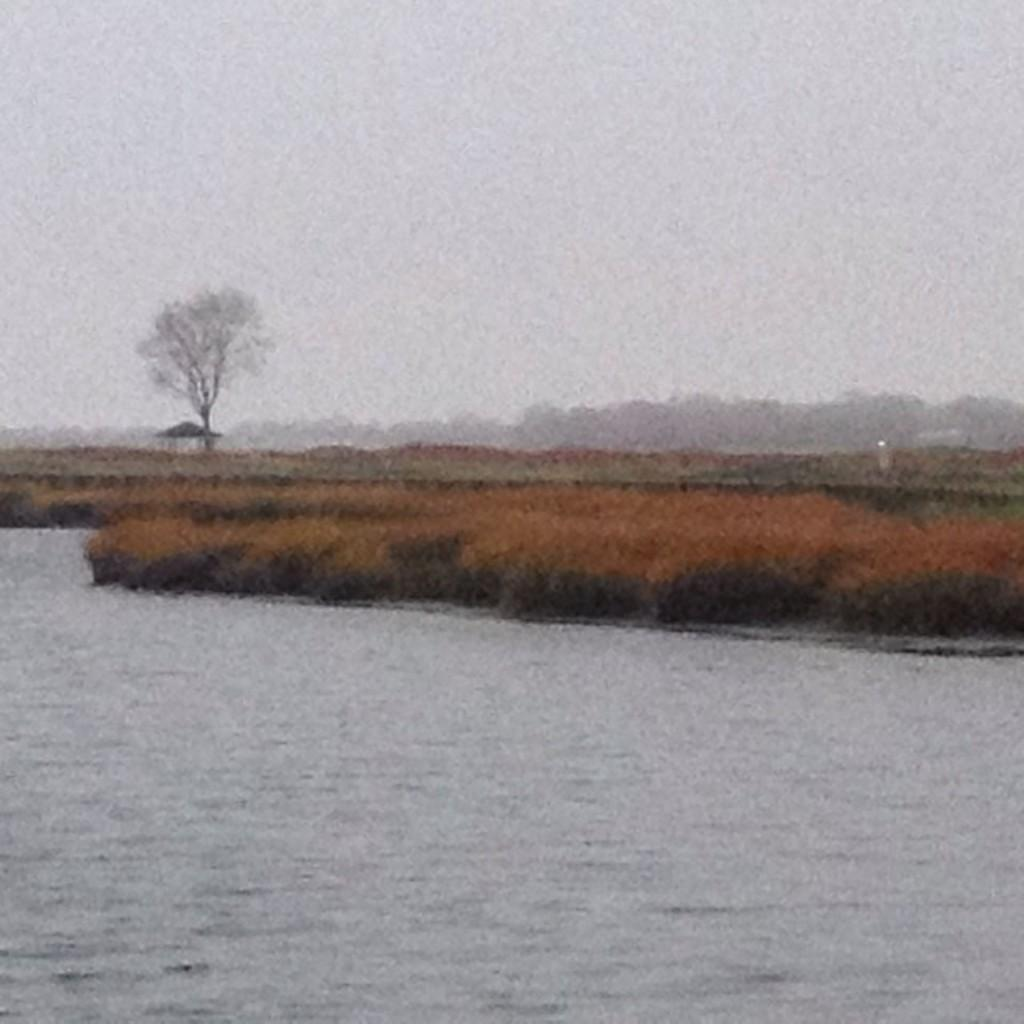What is one of the natural elements present in the image? There is water in the image. What type of vegetation can be seen in the image? There is grass and a tree in the image. What is the condition of the area behind the tree? The area behind the tree is covered with fog. Can you describe the porter's uniform in the image? There is no porter present in the image. What type of bee can be seen buzzing around the tree in the image? There are no bees visible in the image. 